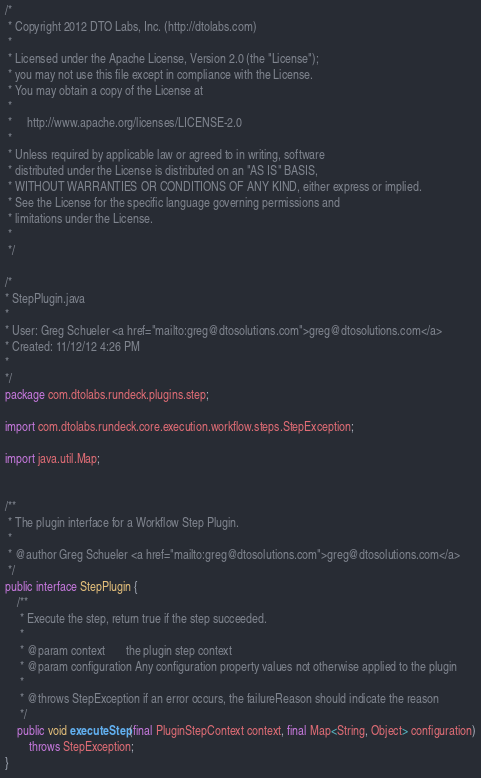<code> <loc_0><loc_0><loc_500><loc_500><_Java_>/*
 * Copyright 2012 DTO Labs, Inc. (http://dtolabs.com)
 * 
 * Licensed under the Apache License, Version 2.0 (the "License");
 * you may not use this file except in compliance with the License.
 * You may obtain a copy of the License at
 *
 *     http://www.apache.org/licenses/LICENSE-2.0
 *
 * Unless required by applicable law or agreed to in writing, software
 * distributed under the License is distributed on an "AS IS" BASIS,
 * WITHOUT WARRANTIES OR CONDITIONS OF ANY KIND, either express or implied.
 * See the License for the specific language governing permissions and
 * limitations under the License.
 *
 */

/*
* StepPlugin.java
* 
* User: Greg Schueler <a href="mailto:greg@dtosolutions.com">greg@dtosolutions.com</a>
* Created: 11/12/12 4:26 PM
* 
*/
package com.dtolabs.rundeck.plugins.step;

import com.dtolabs.rundeck.core.execution.workflow.steps.StepException;

import java.util.Map;


/**
 * The plugin interface for a Workflow Step Plugin.
 *
 * @author Greg Schueler <a href="mailto:greg@dtosolutions.com">greg@dtosolutions.com</a>
 */
public interface StepPlugin {
    /**
     * Execute the step, return true if the step succeeded.
     *
     * @param context       the plugin step context
     * @param configuration Any configuration property values not otherwise applied to the plugin
     *
     * @throws StepException if an error occurs, the failureReason should indicate the reason
     */
    public void executeStep(final PluginStepContext context, final Map<String, Object> configuration)
        throws StepException;
}
</code> 